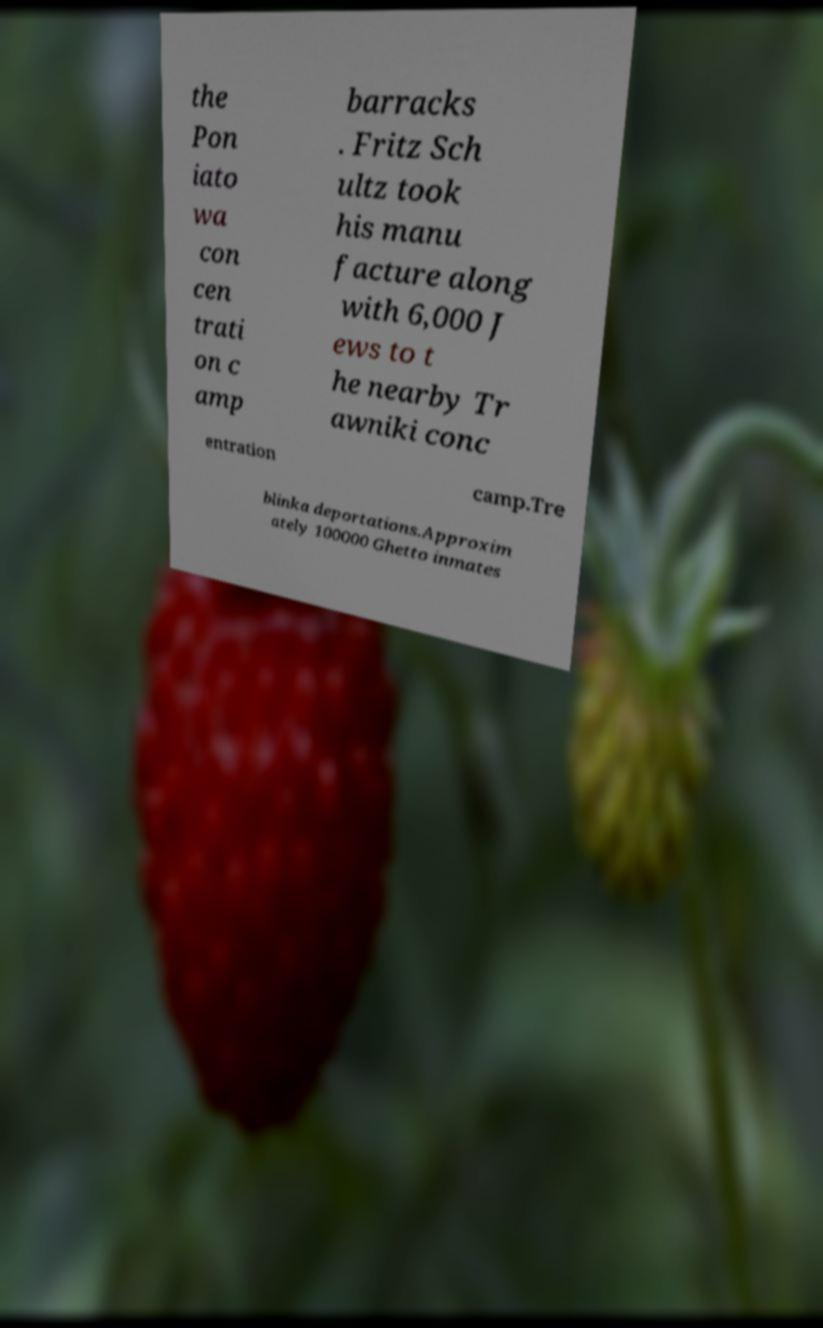Can you read and provide the text displayed in the image?This photo seems to have some interesting text. Can you extract and type it out for me? the Pon iato wa con cen trati on c amp barracks . Fritz Sch ultz took his manu facture along with 6,000 J ews to t he nearby Tr awniki conc entration camp.Tre blinka deportations.Approxim ately 100000 Ghetto inmates 